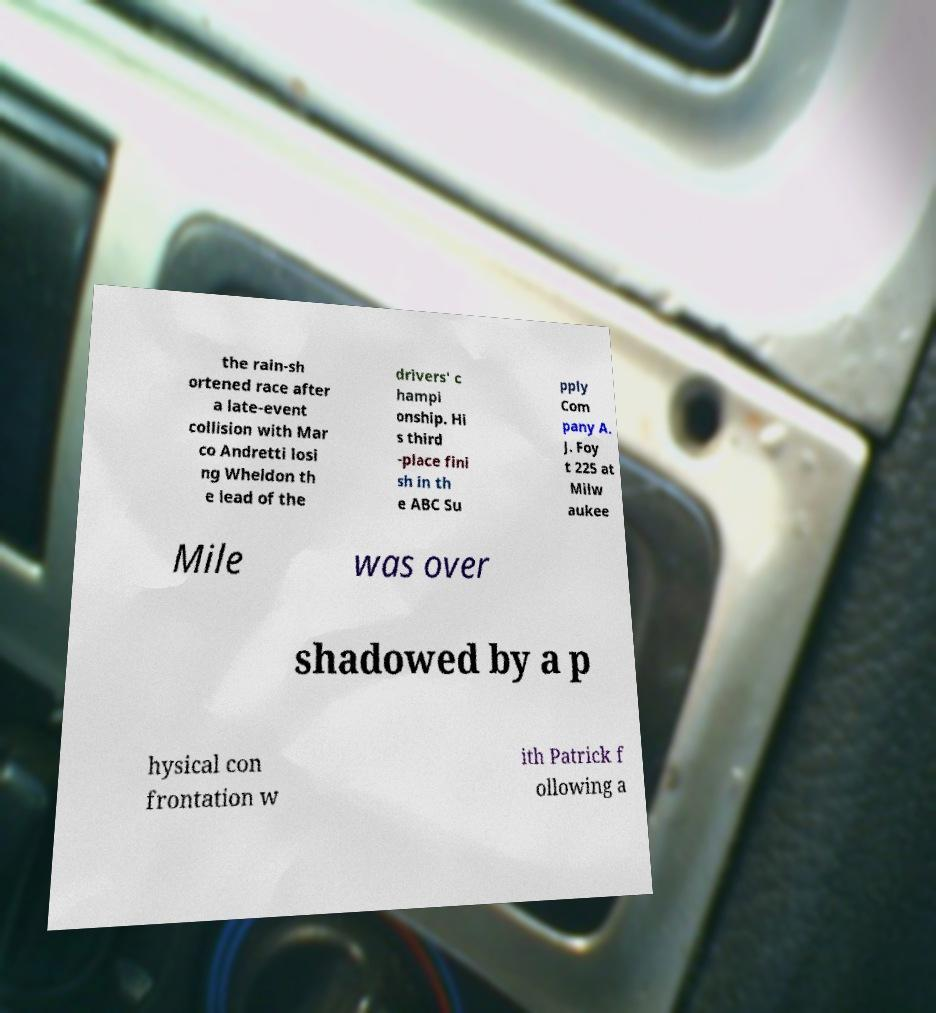Can you read and provide the text displayed in the image?This photo seems to have some interesting text. Can you extract and type it out for me? the rain-sh ortened race after a late-event collision with Mar co Andretti losi ng Wheldon th e lead of the drivers' c hampi onship. Hi s third -place fini sh in th e ABC Su pply Com pany A. J. Foy t 225 at Milw aukee Mile was over shadowed by a p hysical con frontation w ith Patrick f ollowing a 